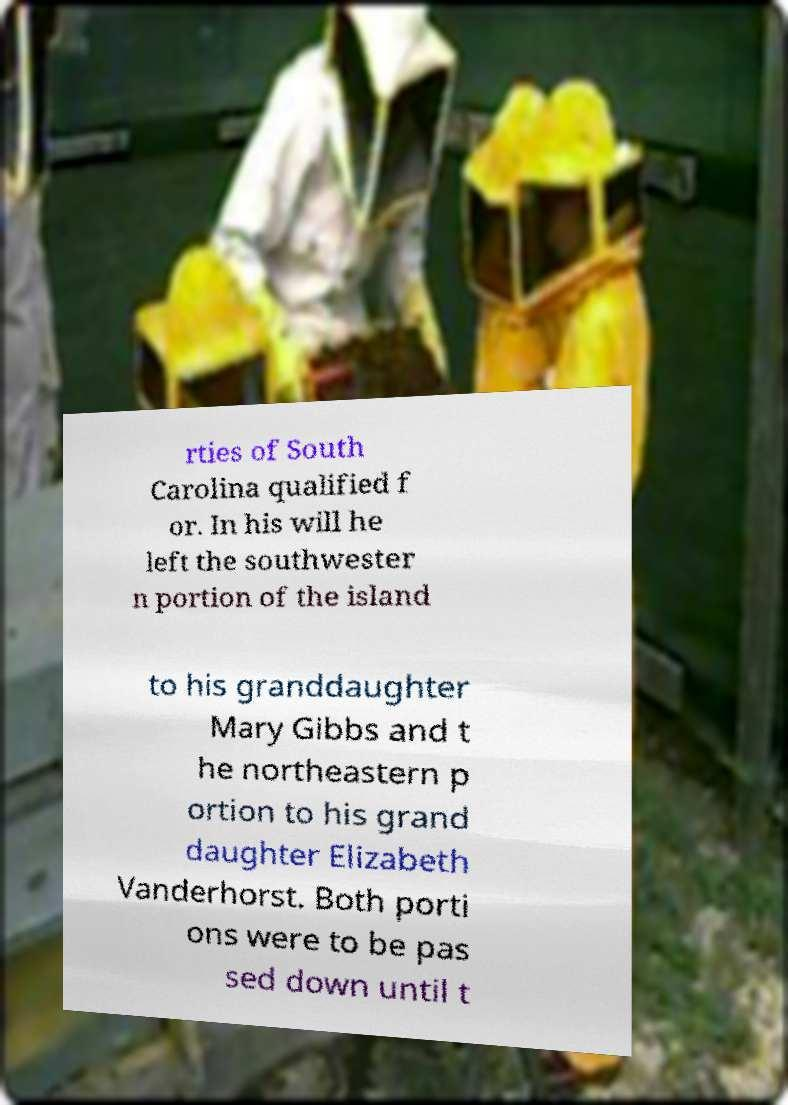For documentation purposes, I need the text within this image transcribed. Could you provide that? rties of South Carolina qualified f or. In his will he left the southwester n portion of the island to his granddaughter Mary Gibbs and t he northeastern p ortion to his grand daughter Elizabeth Vanderhorst. Both porti ons were to be pas sed down until t 